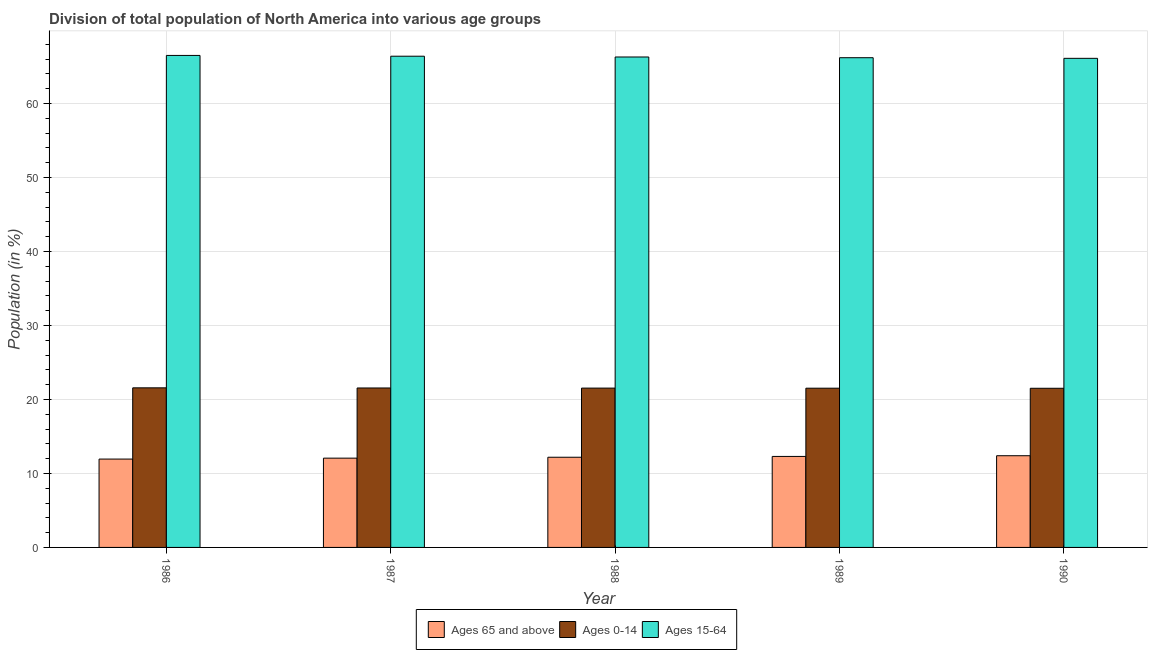How many different coloured bars are there?
Your response must be concise. 3. How many groups of bars are there?
Provide a short and direct response. 5. How many bars are there on the 2nd tick from the right?
Keep it short and to the point. 3. What is the percentage of population within the age-group 15-64 in 1987?
Your answer should be compact. 66.39. Across all years, what is the maximum percentage of population within the age-group 0-14?
Your response must be concise. 21.57. Across all years, what is the minimum percentage of population within the age-group of 65 and above?
Your answer should be compact. 11.94. In which year was the percentage of population within the age-group 15-64 maximum?
Provide a succinct answer. 1986. In which year was the percentage of population within the age-group 0-14 minimum?
Give a very brief answer. 1990. What is the total percentage of population within the age-group 15-64 in the graph?
Ensure brevity in your answer.  331.44. What is the difference between the percentage of population within the age-group 15-64 in 1988 and that in 1990?
Give a very brief answer. 0.18. What is the difference between the percentage of population within the age-group of 65 and above in 1987 and the percentage of population within the age-group 0-14 in 1990?
Keep it short and to the point. -0.33. What is the average percentage of population within the age-group of 65 and above per year?
Provide a succinct answer. 12.18. In the year 1988, what is the difference between the percentage of population within the age-group 15-64 and percentage of population within the age-group of 65 and above?
Your answer should be very brief. 0. What is the ratio of the percentage of population within the age-group 15-64 in 1988 to that in 1989?
Provide a short and direct response. 1. Is the difference between the percentage of population within the age-group of 65 and above in 1986 and 1988 greater than the difference between the percentage of population within the age-group 0-14 in 1986 and 1988?
Your answer should be very brief. No. What is the difference between the highest and the second highest percentage of population within the age-group of 65 and above?
Your answer should be very brief. 0.09. What is the difference between the highest and the lowest percentage of population within the age-group 0-14?
Give a very brief answer. 0.06. In how many years, is the percentage of population within the age-group 0-14 greater than the average percentage of population within the age-group 0-14 taken over all years?
Provide a succinct answer. 2. What does the 3rd bar from the left in 1986 represents?
Offer a very short reply. Ages 15-64. What does the 1st bar from the right in 1990 represents?
Offer a very short reply. Ages 15-64. How many years are there in the graph?
Make the answer very short. 5. Does the graph contain any zero values?
Your answer should be compact. No. How many legend labels are there?
Your response must be concise. 3. How are the legend labels stacked?
Your answer should be compact. Horizontal. What is the title of the graph?
Make the answer very short. Division of total population of North America into various age groups
. What is the label or title of the X-axis?
Keep it short and to the point. Year. What is the Population (in %) of Ages 65 and above in 1986?
Provide a short and direct response. 11.94. What is the Population (in %) in Ages 0-14 in 1986?
Provide a short and direct response. 21.57. What is the Population (in %) in Ages 15-64 in 1986?
Give a very brief answer. 66.49. What is the Population (in %) of Ages 65 and above in 1987?
Keep it short and to the point. 12.06. What is the Population (in %) in Ages 0-14 in 1987?
Keep it short and to the point. 21.55. What is the Population (in %) in Ages 15-64 in 1987?
Provide a short and direct response. 66.39. What is the Population (in %) in Ages 65 and above in 1988?
Provide a short and direct response. 12.19. What is the Population (in %) in Ages 0-14 in 1988?
Offer a very short reply. 21.53. What is the Population (in %) in Ages 15-64 in 1988?
Your answer should be compact. 66.28. What is the Population (in %) in Ages 65 and above in 1989?
Keep it short and to the point. 12.3. What is the Population (in %) in Ages 0-14 in 1989?
Offer a very short reply. 21.52. What is the Population (in %) in Ages 15-64 in 1989?
Your response must be concise. 66.18. What is the Population (in %) in Ages 65 and above in 1990?
Make the answer very short. 12.39. What is the Population (in %) of Ages 0-14 in 1990?
Your response must be concise. 21.51. What is the Population (in %) in Ages 15-64 in 1990?
Keep it short and to the point. 66.1. Across all years, what is the maximum Population (in %) of Ages 65 and above?
Ensure brevity in your answer.  12.39. Across all years, what is the maximum Population (in %) of Ages 0-14?
Offer a terse response. 21.57. Across all years, what is the maximum Population (in %) of Ages 15-64?
Offer a terse response. 66.49. Across all years, what is the minimum Population (in %) in Ages 65 and above?
Your answer should be compact. 11.94. Across all years, what is the minimum Population (in %) in Ages 0-14?
Your answer should be very brief. 21.51. Across all years, what is the minimum Population (in %) of Ages 15-64?
Offer a terse response. 66.1. What is the total Population (in %) of Ages 65 and above in the graph?
Provide a succinct answer. 60.88. What is the total Population (in %) in Ages 0-14 in the graph?
Provide a succinct answer. 107.68. What is the total Population (in %) in Ages 15-64 in the graph?
Your answer should be compact. 331.44. What is the difference between the Population (in %) in Ages 65 and above in 1986 and that in 1987?
Ensure brevity in your answer.  -0.12. What is the difference between the Population (in %) in Ages 0-14 in 1986 and that in 1987?
Offer a very short reply. 0.02. What is the difference between the Population (in %) of Ages 15-64 in 1986 and that in 1987?
Ensure brevity in your answer.  0.11. What is the difference between the Population (in %) of Ages 65 and above in 1986 and that in 1988?
Your response must be concise. -0.25. What is the difference between the Population (in %) in Ages 0-14 in 1986 and that in 1988?
Your answer should be very brief. 0.04. What is the difference between the Population (in %) in Ages 15-64 in 1986 and that in 1988?
Provide a succinct answer. 0.21. What is the difference between the Population (in %) of Ages 65 and above in 1986 and that in 1989?
Ensure brevity in your answer.  -0.36. What is the difference between the Population (in %) in Ages 0-14 in 1986 and that in 1989?
Offer a terse response. 0.05. What is the difference between the Population (in %) in Ages 15-64 in 1986 and that in 1989?
Offer a very short reply. 0.31. What is the difference between the Population (in %) of Ages 65 and above in 1986 and that in 1990?
Give a very brief answer. -0.45. What is the difference between the Population (in %) in Ages 0-14 in 1986 and that in 1990?
Your answer should be very brief. 0.06. What is the difference between the Population (in %) in Ages 15-64 in 1986 and that in 1990?
Your response must be concise. 0.39. What is the difference between the Population (in %) in Ages 65 and above in 1987 and that in 1988?
Your answer should be compact. -0.12. What is the difference between the Population (in %) in Ages 0-14 in 1987 and that in 1988?
Your response must be concise. 0.02. What is the difference between the Population (in %) in Ages 15-64 in 1987 and that in 1988?
Ensure brevity in your answer.  0.11. What is the difference between the Population (in %) of Ages 65 and above in 1987 and that in 1989?
Offer a very short reply. -0.23. What is the difference between the Population (in %) in Ages 0-14 in 1987 and that in 1989?
Offer a terse response. 0.03. What is the difference between the Population (in %) of Ages 15-64 in 1987 and that in 1989?
Offer a very short reply. 0.2. What is the difference between the Population (in %) of Ages 65 and above in 1987 and that in 1990?
Make the answer very short. -0.33. What is the difference between the Population (in %) in Ages 0-14 in 1987 and that in 1990?
Give a very brief answer. 0.04. What is the difference between the Population (in %) in Ages 15-64 in 1987 and that in 1990?
Give a very brief answer. 0.29. What is the difference between the Population (in %) of Ages 65 and above in 1988 and that in 1989?
Give a very brief answer. -0.11. What is the difference between the Population (in %) in Ages 0-14 in 1988 and that in 1989?
Provide a short and direct response. 0.01. What is the difference between the Population (in %) of Ages 15-64 in 1988 and that in 1989?
Offer a terse response. 0.1. What is the difference between the Population (in %) in Ages 65 and above in 1988 and that in 1990?
Ensure brevity in your answer.  -0.21. What is the difference between the Population (in %) of Ages 0-14 in 1988 and that in 1990?
Your answer should be compact. 0.02. What is the difference between the Population (in %) of Ages 15-64 in 1988 and that in 1990?
Provide a short and direct response. 0.18. What is the difference between the Population (in %) in Ages 65 and above in 1989 and that in 1990?
Your response must be concise. -0.09. What is the difference between the Population (in %) of Ages 0-14 in 1989 and that in 1990?
Your answer should be compact. 0.01. What is the difference between the Population (in %) of Ages 15-64 in 1989 and that in 1990?
Your answer should be compact. 0.08. What is the difference between the Population (in %) of Ages 65 and above in 1986 and the Population (in %) of Ages 0-14 in 1987?
Make the answer very short. -9.61. What is the difference between the Population (in %) of Ages 65 and above in 1986 and the Population (in %) of Ages 15-64 in 1987?
Your response must be concise. -54.45. What is the difference between the Population (in %) of Ages 0-14 in 1986 and the Population (in %) of Ages 15-64 in 1987?
Make the answer very short. -44.82. What is the difference between the Population (in %) of Ages 65 and above in 1986 and the Population (in %) of Ages 0-14 in 1988?
Offer a terse response. -9.59. What is the difference between the Population (in %) in Ages 65 and above in 1986 and the Population (in %) in Ages 15-64 in 1988?
Provide a short and direct response. -54.34. What is the difference between the Population (in %) of Ages 0-14 in 1986 and the Population (in %) of Ages 15-64 in 1988?
Offer a terse response. -44.71. What is the difference between the Population (in %) in Ages 65 and above in 1986 and the Population (in %) in Ages 0-14 in 1989?
Keep it short and to the point. -9.58. What is the difference between the Population (in %) in Ages 65 and above in 1986 and the Population (in %) in Ages 15-64 in 1989?
Give a very brief answer. -54.24. What is the difference between the Population (in %) of Ages 0-14 in 1986 and the Population (in %) of Ages 15-64 in 1989?
Provide a succinct answer. -44.61. What is the difference between the Population (in %) in Ages 65 and above in 1986 and the Population (in %) in Ages 0-14 in 1990?
Your answer should be compact. -9.57. What is the difference between the Population (in %) of Ages 65 and above in 1986 and the Population (in %) of Ages 15-64 in 1990?
Give a very brief answer. -54.16. What is the difference between the Population (in %) of Ages 0-14 in 1986 and the Population (in %) of Ages 15-64 in 1990?
Provide a short and direct response. -44.53. What is the difference between the Population (in %) of Ages 65 and above in 1987 and the Population (in %) of Ages 0-14 in 1988?
Offer a terse response. -9.47. What is the difference between the Population (in %) of Ages 65 and above in 1987 and the Population (in %) of Ages 15-64 in 1988?
Your answer should be very brief. -54.22. What is the difference between the Population (in %) in Ages 0-14 in 1987 and the Population (in %) in Ages 15-64 in 1988?
Offer a very short reply. -44.73. What is the difference between the Population (in %) in Ages 65 and above in 1987 and the Population (in %) in Ages 0-14 in 1989?
Ensure brevity in your answer.  -9.46. What is the difference between the Population (in %) of Ages 65 and above in 1987 and the Population (in %) of Ages 15-64 in 1989?
Ensure brevity in your answer.  -54.12. What is the difference between the Population (in %) in Ages 0-14 in 1987 and the Population (in %) in Ages 15-64 in 1989?
Give a very brief answer. -44.63. What is the difference between the Population (in %) in Ages 65 and above in 1987 and the Population (in %) in Ages 0-14 in 1990?
Give a very brief answer. -9.45. What is the difference between the Population (in %) in Ages 65 and above in 1987 and the Population (in %) in Ages 15-64 in 1990?
Offer a very short reply. -54.03. What is the difference between the Population (in %) in Ages 0-14 in 1987 and the Population (in %) in Ages 15-64 in 1990?
Make the answer very short. -44.55. What is the difference between the Population (in %) of Ages 65 and above in 1988 and the Population (in %) of Ages 0-14 in 1989?
Offer a terse response. -9.33. What is the difference between the Population (in %) in Ages 65 and above in 1988 and the Population (in %) in Ages 15-64 in 1989?
Provide a short and direct response. -54. What is the difference between the Population (in %) of Ages 0-14 in 1988 and the Population (in %) of Ages 15-64 in 1989?
Make the answer very short. -44.65. What is the difference between the Population (in %) of Ages 65 and above in 1988 and the Population (in %) of Ages 0-14 in 1990?
Give a very brief answer. -9.32. What is the difference between the Population (in %) of Ages 65 and above in 1988 and the Population (in %) of Ages 15-64 in 1990?
Provide a succinct answer. -53.91. What is the difference between the Population (in %) of Ages 0-14 in 1988 and the Population (in %) of Ages 15-64 in 1990?
Your answer should be compact. -44.57. What is the difference between the Population (in %) in Ages 65 and above in 1989 and the Population (in %) in Ages 0-14 in 1990?
Your response must be concise. -9.21. What is the difference between the Population (in %) in Ages 65 and above in 1989 and the Population (in %) in Ages 15-64 in 1990?
Make the answer very short. -53.8. What is the difference between the Population (in %) of Ages 0-14 in 1989 and the Population (in %) of Ages 15-64 in 1990?
Offer a very short reply. -44.58. What is the average Population (in %) in Ages 65 and above per year?
Give a very brief answer. 12.18. What is the average Population (in %) of Ages 0-14 per year?
Offer a terse response. 21.54. What is the average Population (in %) in Ages 15-64 per year?
Your answer should be very brief. 66.29. In the year 1986, what is the difference between the Population (in %) in Ages 65 and above and Population (in %) in Ages 0-14?
Give a very brief answer. -9.63. In the year 1986, what is the difference between the Population (in %) in Ages 65 and above and Population (in %) in Ages 15-64?
Offer a very short reply. -54.55. In the year 1986, what is the difference between the Population (in %) in Ages 0-14 and Population (in %) in Ages 15-64?
Offer a very short reply. -44.92. In the year 1987, what is the difference between the Population (in %) of Ages 65 and above and Population (in %) of Ages 0-14?
Your answer should be very brief. -9.48. In the year 1987, what is the difference between the Population (in %) of Ages 65 and above and Population (in %) of Ages 15-64?
Keep it short and to the point. -54.32. In the year 1987, what is the difference between the Population (in %) in Ages 0-14 and Population (in %) in Ages 15-64?
Give a very brief answer. -44.84. In the year 1988, what is the difference between the Population (in %) in Ages 65 and above and Population (in %) in Ages 0-14?
Your answer should be very brief. -9.35. In the year 1988, what is the difference between the Population (in %) in Ages 65 and above and Population (in %) in Ages 15-64?
Your response must be concise. -54.09. In the year 1988, what is the difference between the Population (in %) in Ages 0-14 and Population (in %) in Ages 15-64?
Your answer should be very brief. -44.75. In the year 1989, what is the difference between the Population (in %) in Ages 65 and above and Population (in %) in Ages 0-14?
Offer a terse response. -9.22. In the year 1989, what is the difference between the Population (in %) of Ages 65 and above and Population (in %) of Ages 15-64?
Keep it short and to the point. -53.88. In the year 1989, what is the difference between the Population (in %) in Ages 0-14 and Population (in %) in Ages 15-64?
Ensure brevity in your answer.  -44.66. In the year 1990, what is the difference between the Population (in %) in Ages 65 and above and Population (in %) in Ages 0-14?
Your answer should be compact. -9.12. In the year 1990, what is the difference between the Population (in %) of Ages 65 and above and Population (in %) of Ages 15-64?
Your answer should be very brief. -53.71. In the year 1990, what is the difference between the Population (in %) of Ages 0-14 and Population (in %) of Ages 15-64?
Provide a succinct answer. -44.59. What is the ratio of the Population (in %) in Ages 0-14 in 1986 to that in 1987?
Make the answer very short. 1. What is the ratio of the Population (in %) of Ages 15-64 in 1986 to that in 1987?
Give a very brief answer. 1. What is the ratio of the Population (in %) in Ages 65 and above in 1986 to that in 1988?
Your answer should be very brief. 0.98. What is the ratio of the Population (in %) of Ages 15-64 in 1986 to that in 1988?
Make the answer very short. 1. What is the ratio of the Population (in %) of Ages 65 and above in 1986 to that in 1989?
Keep it short and to the point. 0.97. What is the ratio of the Population (in %) in Ages 15-64 in 1986 to that in 1989?
Your answer should be compact. 1. What is the ratio of the Population (in %) of Ages 65 and above in 1986 to that in 1990?
Provide a succinct answer. 0.96. What is the ratio of the Population (in %) of Ages 15-64 in 1986 to that in 1990?
Offer a terse response. 1.01. What is the ratio of the Population (in %) in Ages 65 and above in 1987 to that in 1988?
Your response must be concise. 0.99. What is the ratio of the Population (in %) in Ages 15-64 in 1987 to that in 1988?
Provide a short and direct response. 1. What is the ratio of the Population (in %) in Ages 65 and above in 1987 to that in 1989?
Give a very brief answer. 0.98. What is the ratio of the Population (in %) in Ages 15-64 in 1987 to that in 1989?
Your response must be concise. 1. What is the ratio of the Population (in %) of Ages 65 and above in 1987 to that in 1990?
Give a very brief answer. 0.97. What is the ratio of the Population (in %) of Ages 0-14 in 1987 to that in 1990?
Provide a short and direct response. 1. What is the ratio of the Population (in %) in Ages 65 and above in 1988 to that in 1989?
Provide a succinct answer. 0.99. What is the ratio of the Population (in %) of Ages 65 and above in 1988 to that in 1990?
Offer a terse response. 0.98. What is the difference between the highest and the second highest Population (in %) in Ages 65 and above?
Keep it short and to the point. 0.09. What is the difference between the highest and the second highest Population (in %) of Ages 0-14?
Your answer should be very brief. 0.02. What is the difference between the highest and the second highest Population (in %) of Ages 15-64?
Provide a short and direct response. 0.11. What is the difference between the highest and the lowest Population (in %) in Ages 65 and above?
Give a very brief answer. 0.45. What is the difference between the highest and the lowest Population (in %) in Ages 0-14?
Your answer should be very brief. 0.06. What is the difference between the highest and the lowest Population (in %) of Ages 15-64?
Give a very brief answer. 0.39. 